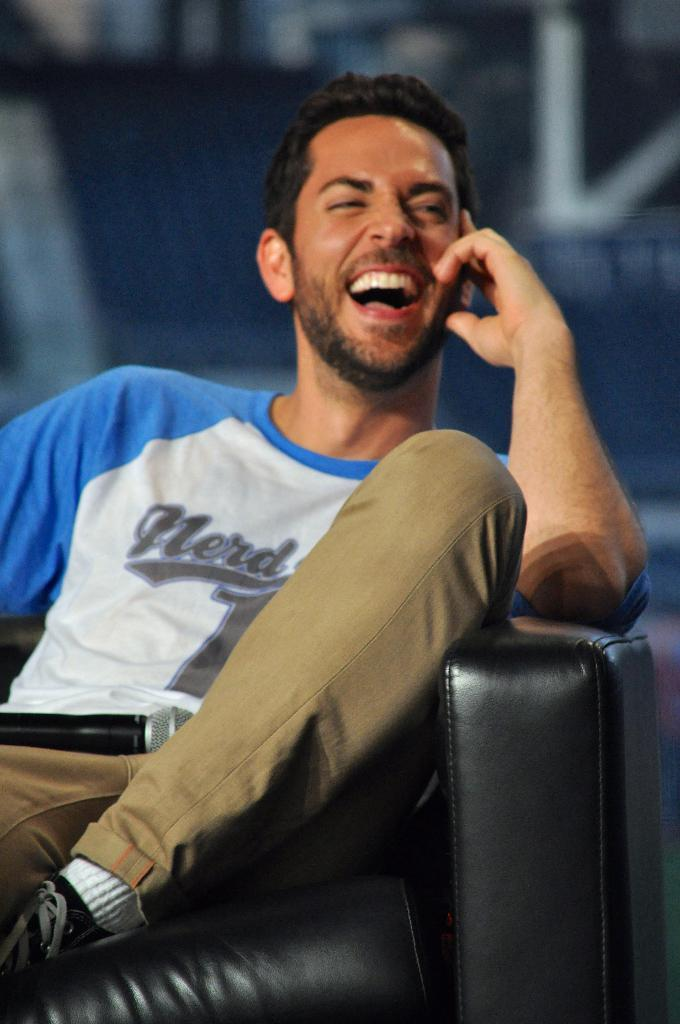What is the person in the image doing? There is a person sitting in the image. Can you describe the person's clothing? The person is wearing a dress with blue, white, and brown colors. What object is present in the image that is typically used for amplifying sound? There is a microphone in the image. How would you describe the background of the image? The background of the image is blurred. What type of waste can be seen in the image? There is no waste present in the image. What type of land is visible in the image? The image does not show any land; it is focused on a person sitting with a microphone. 